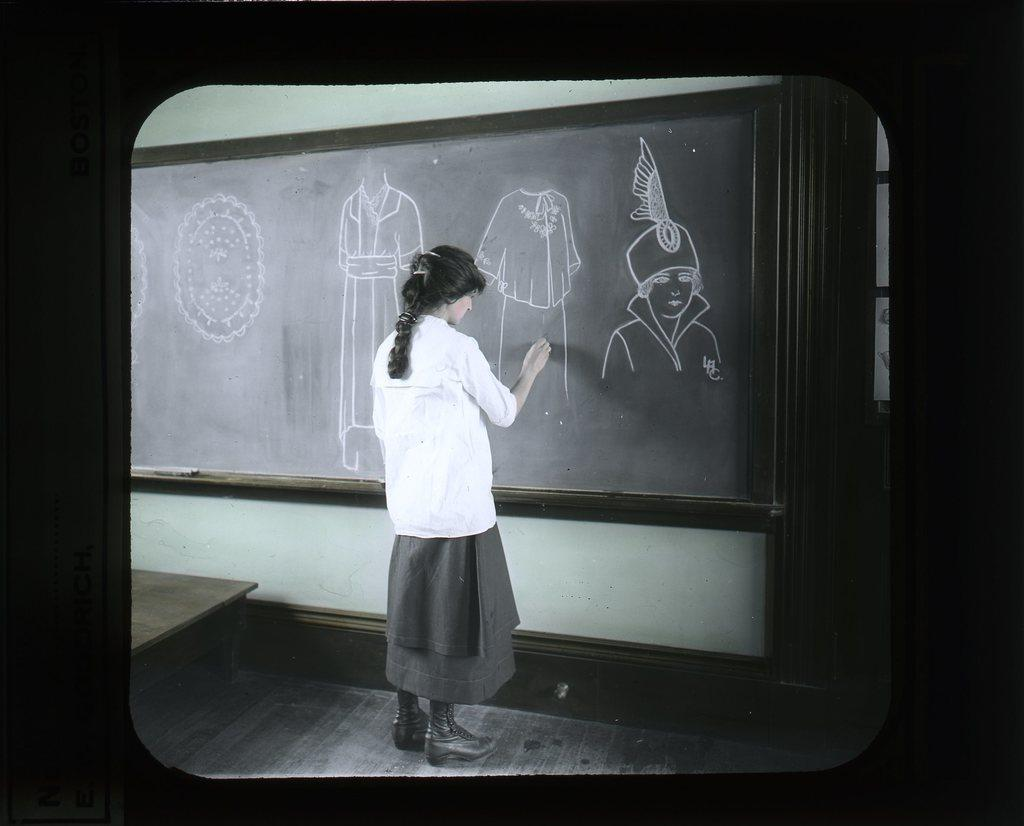Who is the main subject in the image? There is a woman in the image. What is the woman doing in the image? The woman is drawing on a blackboard. What can be seen on the blackboard besides the woman's drawing? There are drawings on the blackboard. What piece of furniture is present in the image? There is a table in the image. What type of crook is observing the woman's drawing in the image? There is no crook present in the image, and no one is observing the woman's drawing. 